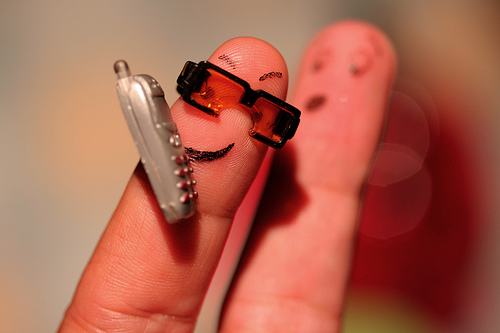<image>
Can you confirm if the phone is to the left of the sunglasses? Yes. From this viewpoint, the phone is positioned to the left side relative to the sunglasses. Where is the glasses in relation to the finger? Is it next to the finger? Yes. The glasses is positioned adjacent to the finger, located nearby in the same general area. 